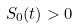<formula> <loc_0><loc_0><loc_500><loc_500>S _ { 0 } ( t ) > 0</formula> 